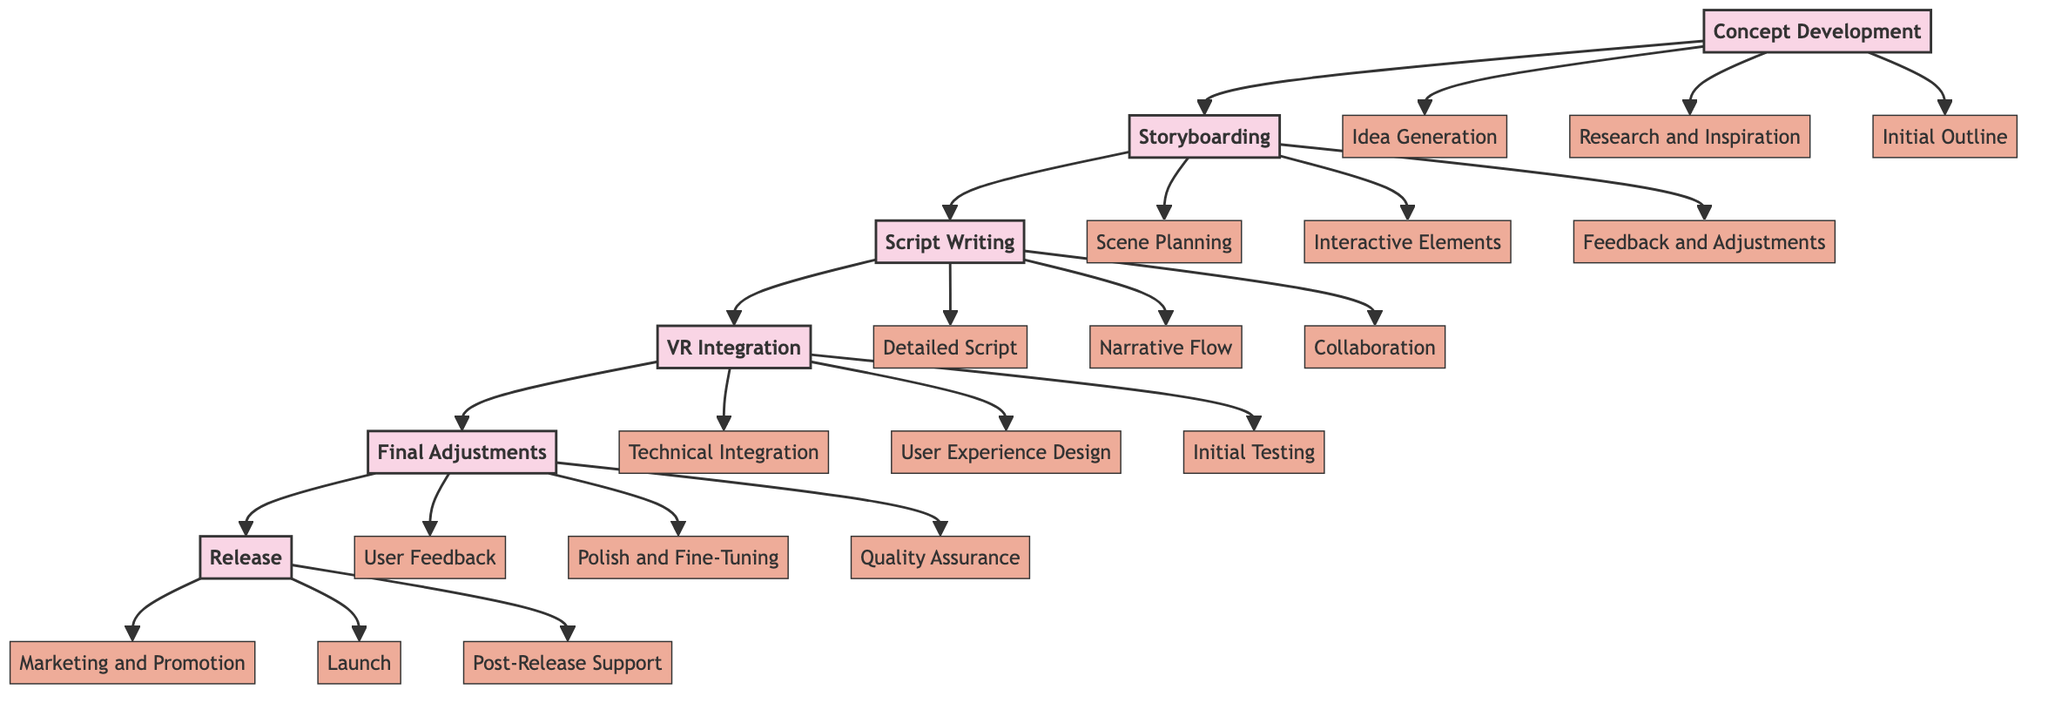What is the first node in the diagram? The first node is "Concept Development", which is positioned at the top of the flowchart, indicating the starting point of the development process.
Answer: Concept Development How many main nodes are there in the diagram? There are six main nodes indicated in the diagram, representing different stages in the evolution of a virtual reality storyline.
Answer: 6 What is the relationship between "Storyboarding" and "Script Writing"? "Storyboarding" is directly linked to "Script Writing" as the second node in the sequence, showing that it follows "Storyboarding" in the progression of developing a VR storyline.
Answer: Storyboarding leads to Script Writing What are the sub-elements of "VR Integration"? The sub-elements of "VR Integration" are "Technical Integration", "User Experience Design", and "Initial Testing", which provide more detail on that stage of development.
Answer: Technical Integration, User Experience Design, Initial Testing Which node follows "Final Adjustments"? The node that follows "Final Adjustments" is "Release". This indicates that "Final Adjustments" is the last stage before launching the VR storyline.
Answer: Release How many sub-elements does "Concept Development" have? "Concept Development" has three sub-elements, specifically detailing the initial creative processes involved in developing the storyline.
Answer: 3 Which main node contains the sub-element "Collaboration"? The main node that contains the sub-element "Collaboration" is "Script Writing", indicating that collaboration with various stakeholders is crucial during the scripting phase.
Answer: Script Writing What is the final sub-element listed in the diagram? The final sub-element listed is "Post-Release Support", indicating ongoing support and updates following the launch.
Answer: Post-Release Support What stage comes after "VR Integration"? The stage that comes after "VR Integration" is "Final Adjustments", suggesting a need for refinement before release.
Answer: Final Adjustments 